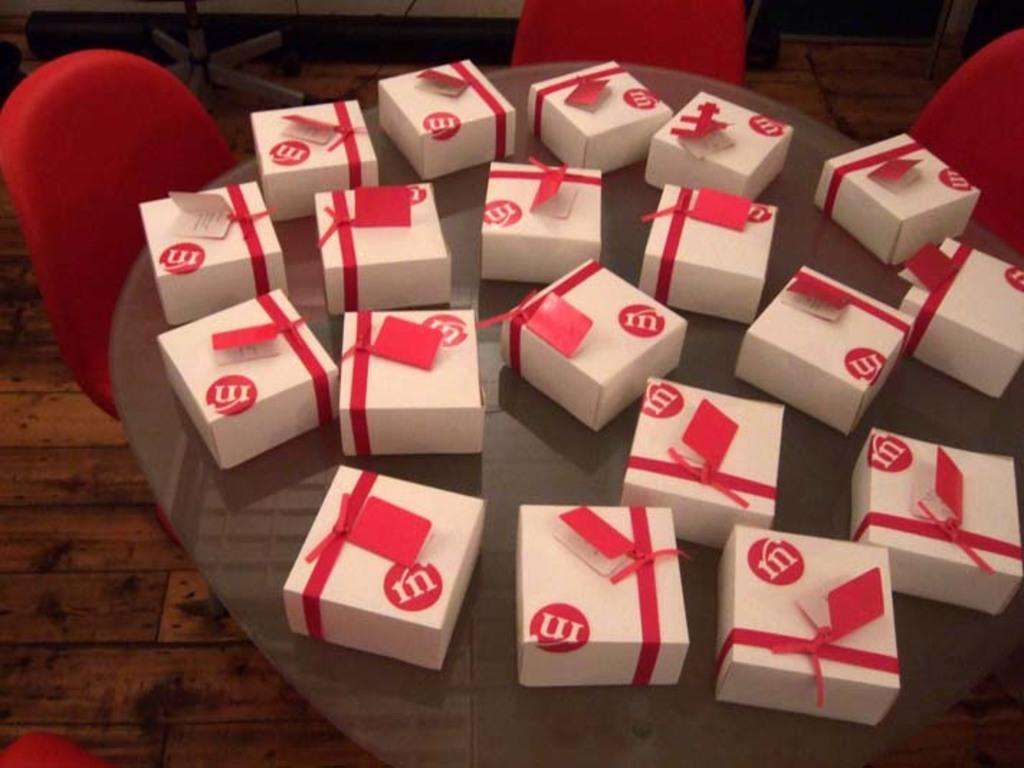<image>
Describe the image concisely. A lot of white and red boxes that have the letter M on the box placed on a table. 